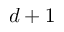Convert formula to latex. <formula><loc_0><loc_0><loc_500><loc_500>d + 1</formula> 